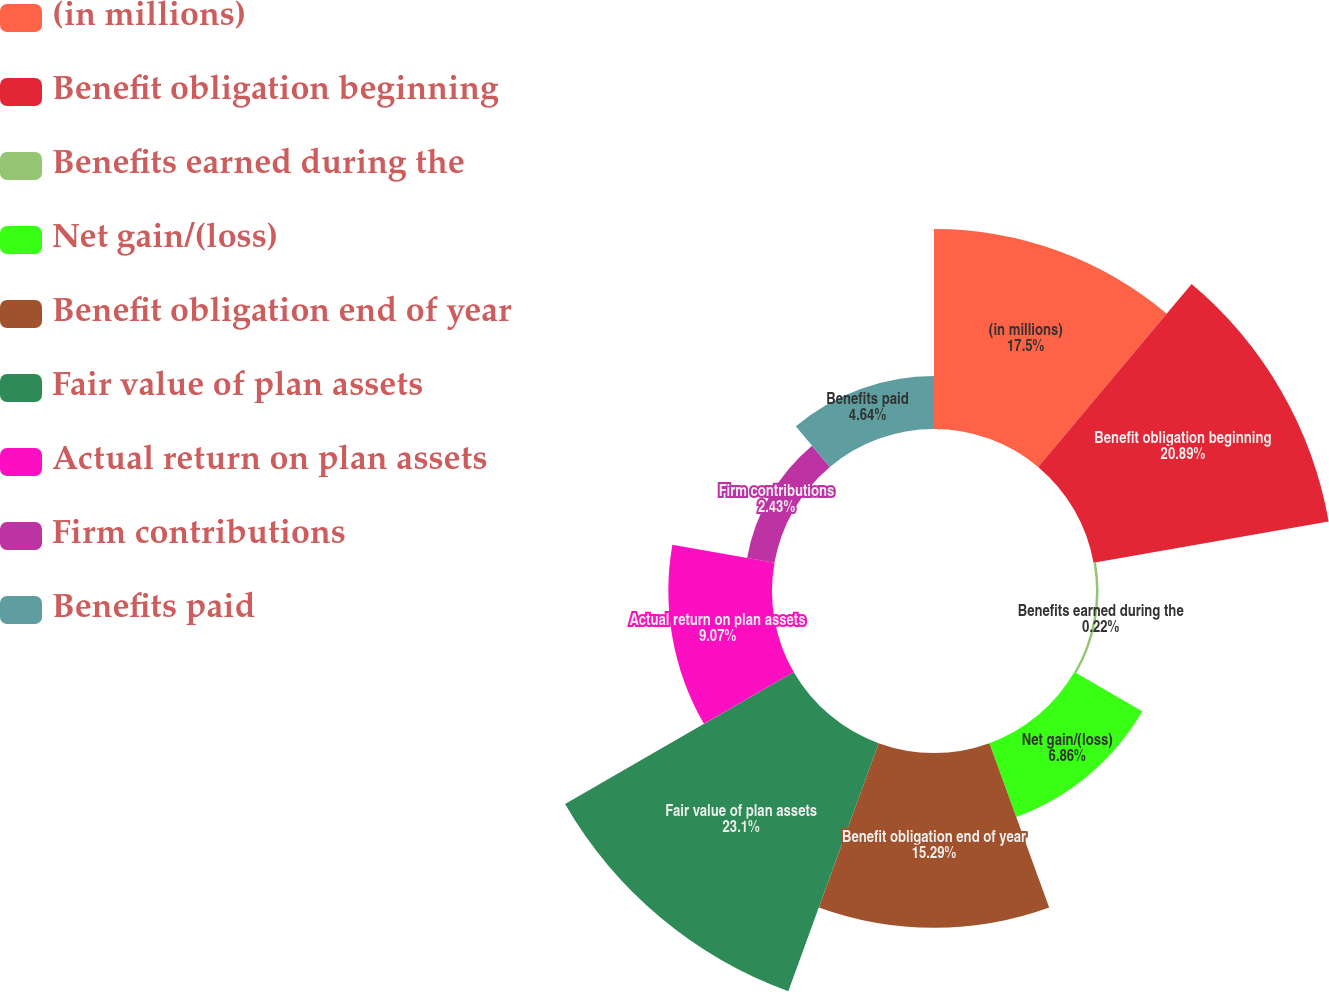Convert chart to OTSL. <chart><loc_0><loc_0><loc_500><loc_500><pie_chart><fcel>(in millions)<fcel>Benefit obligation beginning<fcel>Benefits earned during the<fcel>Net gain/(loss)<fcel>Benefit obligation end of year<fcel>Fair value of plan assets<fcel>Actual return on plan assets<fcel>Firm contributions<fcel>Benefits paid<nl><fcel>17.5%<fcel>20.89%<fcel>0.22%<fcel>6.86%<fcel>15.29%<fcel>23.1%<fcel>9.07%<fcel>2.43%<fcel>4.64%<nl></chart> 